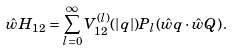<formula> <loc_0><loc_0><loc_500><loc_500>\hat { w } H _ { 1 2 } = \sum _ { l = 0 } ^ { \infty } V ^ { ( l ) } _ { 1 2 } ( | q | ) P _ { l } ( \hat { w } q \cdot \hat { w } Q ) \, .</formula> 